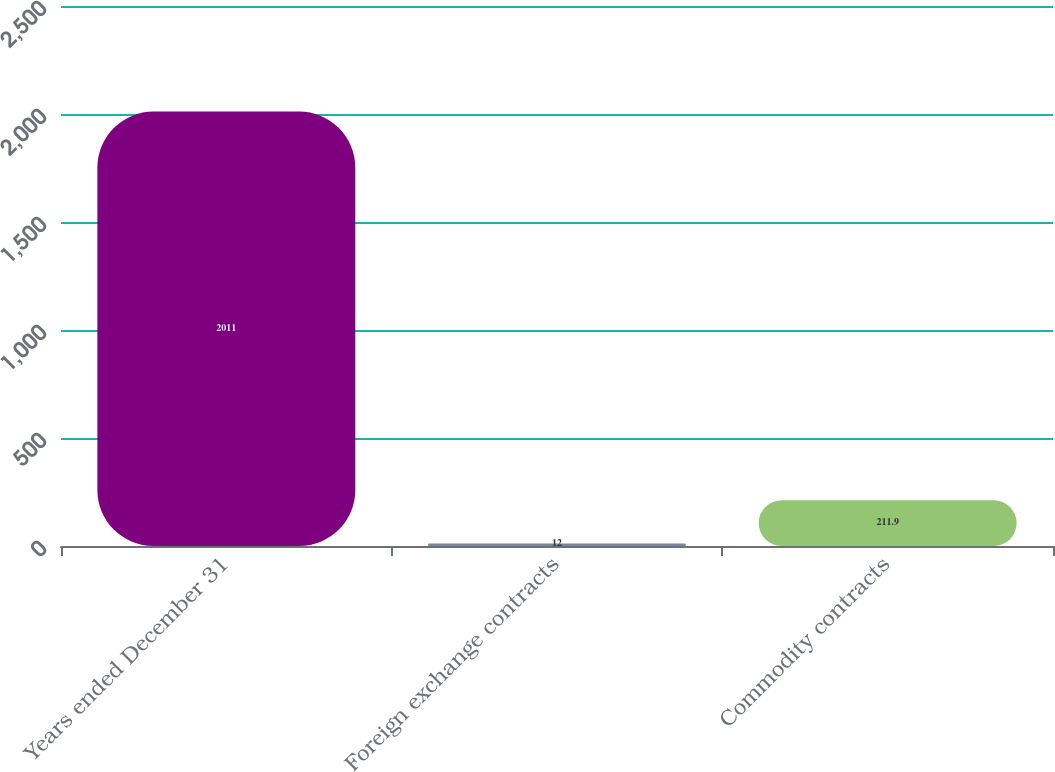Convert chart. <chart><loc_0><loc_0><loc_500><loc_500><bar_chart><fcel>Years ended December 31<fcel>Foreign exchange contracts<fcel>Commodity contracts<nl><fcel>2011<fcel>12<fcel>211.9<nl></chart> 